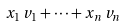<formula> <loc_0><loc_0><loc_500><loc_500>x _ { 1 } \, v _ { 1 } + \cdots + x _ { n } \, v _ { n }</formula> 